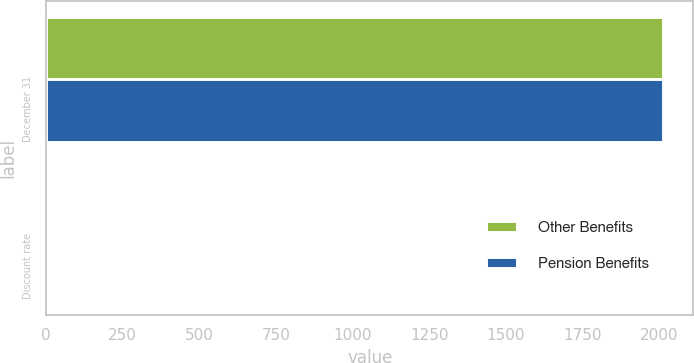Convert chart. <chart><loc_0><loc_0><loc_500><loc_500><stacked_bar_chart><ecel><fcel>December 31<fcel>Discount rate<nl><fcel>Other Benefits<fcel>2011<fcel>4.75<nl><fcel>Pension Benefits<fcel>2011<fcel>4.75<nl></chart> 